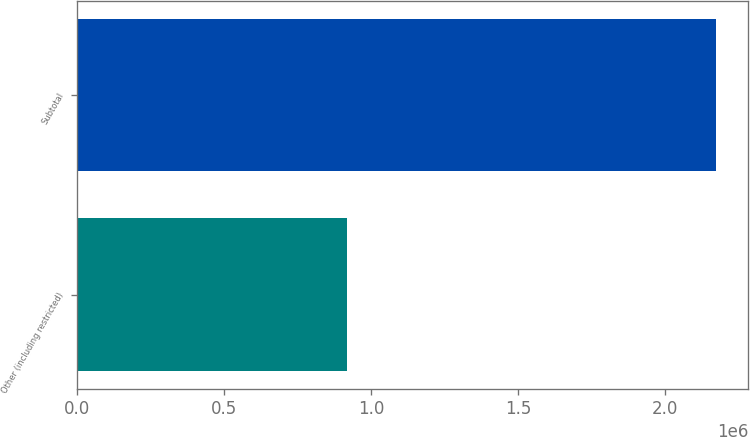Convert chart. <chart><loc_0><loc_0><loc_500><loc_500><bar_chart><fcel>Other (including restricted)<fcel>Subtotal<nl><fcel>917069<fcel>2.1755e+06<nl></chart> 